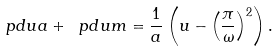Convert formula to latex. <formula><loc_0><loc_0><loc_500><loc_500>\ p d { u } a + \ p d { u } m = \frac { 1 } { a } \left ( { u } - \left ( \frac { \pi } \omega \right ) ^ { 2 } \right ) .</formula> 